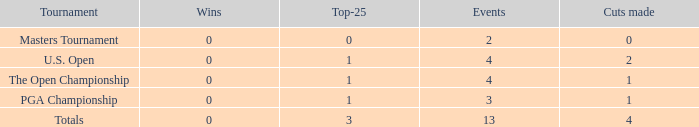How many cuts did he make at the PGA championship in 3 events? None. 